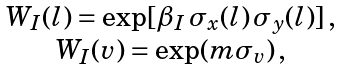<formula> <loc_0><loc_0><loc_500><loc_500>\begin{array} { c } W _ { I } ( l ) = \exp [ \beta _ { I } \, \sigma _ { x } ( l ) \, \sigma _ { y } ( l ) ] \, , \\ W _ { I } ( v ) = \exp ( m \sigma _ { v } ) \, , \end{array}</formula> 